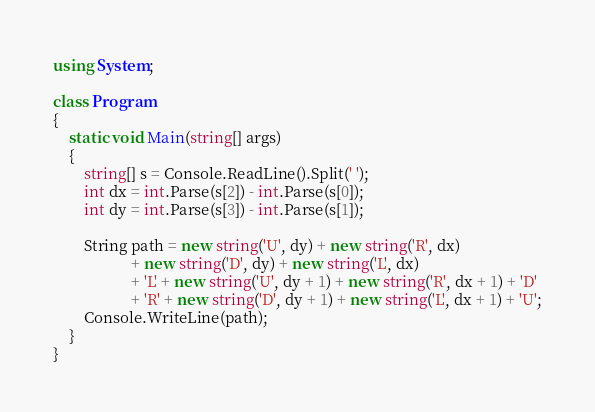Convert code to text. <code><loc_0><loc_0><loc_500><loc_500><_C#_>using System;

class Program
{
    static void Main(string[] args)
    {
        string[] s = Console.ReadLine().Split(' ');
        int dx = int.Parse(s[2]) - int.Parse(s[0]);
        int dy = int.Parse(s[3]) - int.Parse(s[1]);

        String path = new string('U', dy) + new string('R', dx)
                    + new string('D', dy) + new string('L', dx)
                    + 'L' + new string('U', dy + 1) + new string('R', dx + 1) + 'D'
                    + 'R' + new string('D', dy + 1) + new string('L', dx + 1) + 'U';
        Console.WriteLine(path);
    }
}</code> 